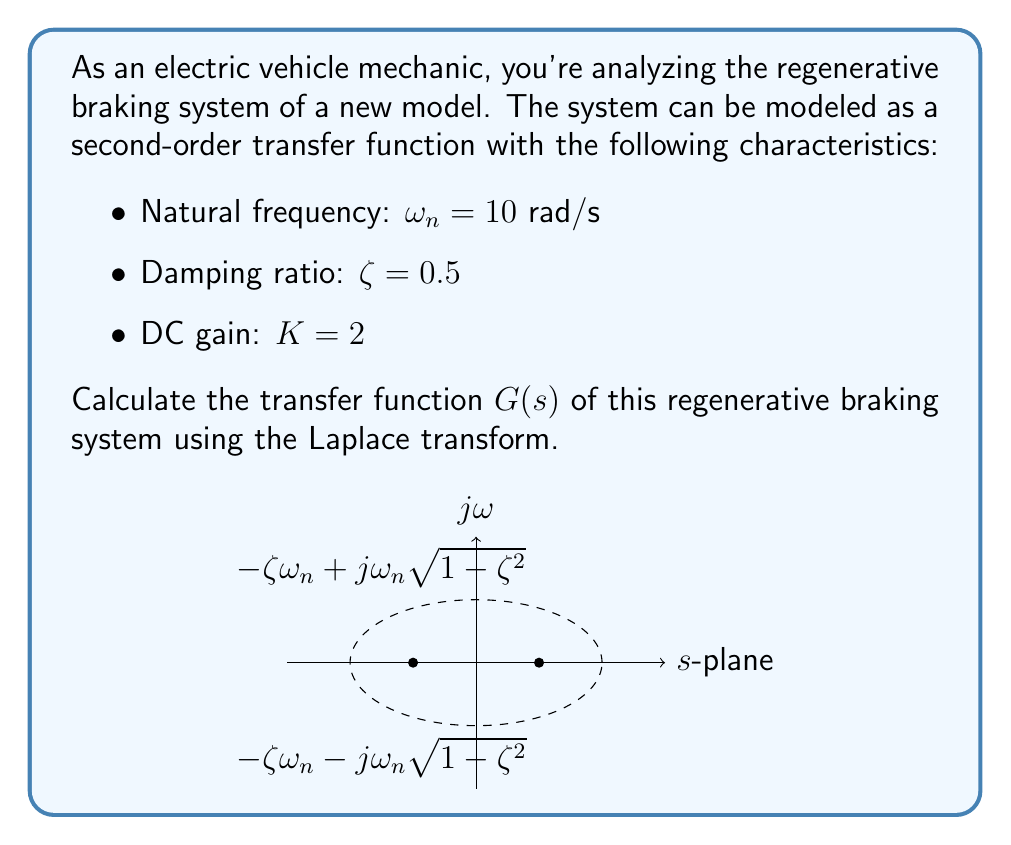Help me with this question. Let's approach this step-by-step:

1) The general form of a second-order transfer function is:

   $$G(s) = \frac{K\omega_n^2}{s^2 + 2\zeta\omega_n s + \omega_n^2}$$

2) We're given:
   - Natural frequency: $\omega_n = 10$ rad/s
   - Damping ratio: $\zeta = 0.5$
   - DC gain: $K = 2$

3) Let's substitute these values into the general form:

   $$G(s) = \frac{2(10)^2}{s^2 + 2(0.5)(10)s + 10^2}$$

4) Simplify:
   
   $$G(s) = \frac{200}{s^2 + 10s + 100}$$

5) This is our final transfer function in the Laplace domain. It represents how the regenerative braking system responds to different input frequencies.

6) We can verify that this function has the correct characteristics:
   - The DC gain (when $s=0$) is indeed 2.
   - The denominator in standard form $s^2 + 2\zeta\omega_n s + \omega_n^2$ matches our given values.

7) The poles of this system are at $s = -5 \pm j5\sqrt{3}$, which corresponds to the damped natural frequency and matches the diagram in the s-plane.
Answer: $$G(s) = \frac{200}{s^2 + 10s + 100}$$ 